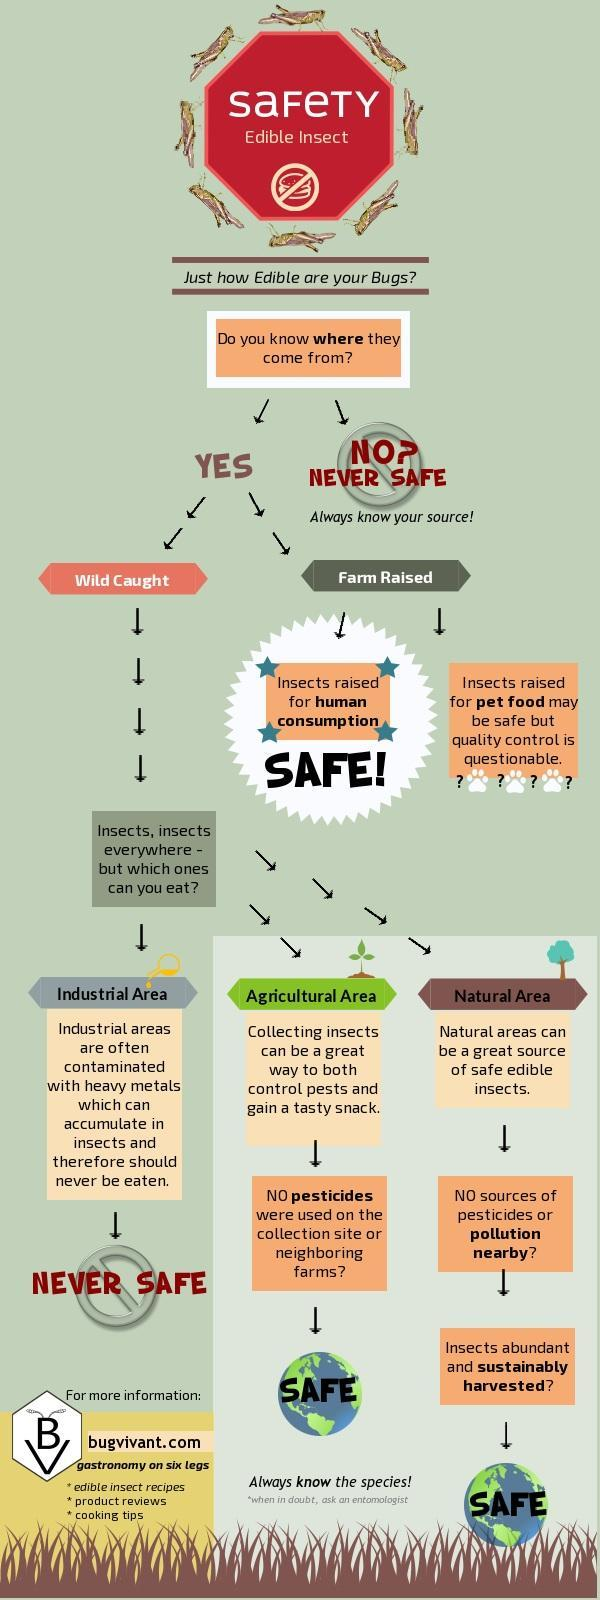Which area edible bugs are never safe for human consumption?
Answer the question with a short phrase. Industrial area How many insect icons are in this infographic? 8 Which areas mentioned in this infographic? Industrial area, Agricultural area, Natural area How many areas mentioned in this infographic? 3 Which all ways to gets insects? Wild caught, Farm Raised 